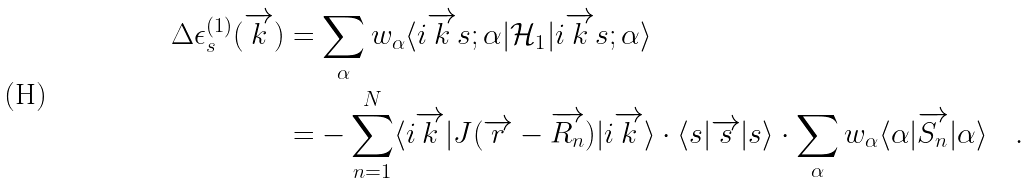<formula> <loc_0><loc_0><loc_500><loc_500>\Delta \epsilon _ { s } ^ { ( 1 ) } ( \overrightarrow { k } ) & = \sum _ { \alpha } w _ { \alpha } \langle i \overrightarrow { k } s ; \alpha | \mathcal { H } _ { 1 } | i \overrightarrow { k } s ; \alpha \rangle \\ & = - \sum _ { n = 1 } ^ { N } \langle i \overrightarrow { k } | J ( \overrightarrow { r } - \overrightarrow { R _ { n } } ) | i \overrightarrow { k } \rangle \cdot \langle s | \overrightarrow { s } | s \rangle \cdot \sum _ { \alpha } w _ { \alpha } \langle \alpha | \overrightarrow { S _ { n } } | \alpha \rangle \quad .</formula> 